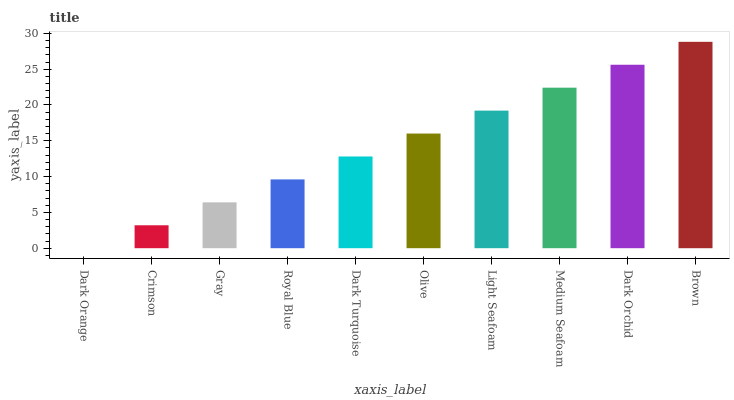Is Dark Orange the minimum?
Answer yes or no. Yes. Is Brown the maximum?
Answer yes or no. Yes. Is Crimson the minimum?
Answer yes or no. No. Is Crimson the maximum?
Answer yes or no. No. Is Crimson greater than Dark Orange?
Answer yes or no. Yes. Is Dark Orange less than Crimson?
Answer yes or no. Yes. Is Dark Orange greater than Crimson?
Answer yes or no. No. Is Crimson less than Dark Orange?
Answer yes or no. No. Is Olive the high median?
Answer yes or no. Yes. Is Dark Turquoise the low median?
Answer yes or no. Yes. Is Light Seafoam the high median?
Answer yes or no. No. Is Crimson the low median?
Answer yes or no. No. 